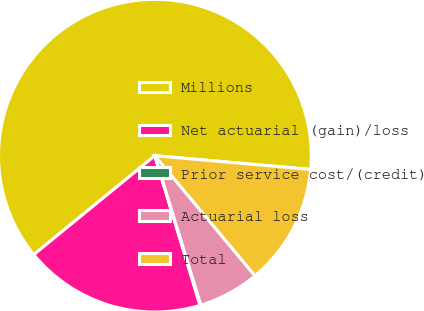<chart> <loc_0><loc_0><loc_500><loc_500><pie_chart><fcel>Millions<fcel>Net actuarial (gain)/loss<fcel>Prior service cost/(credit)<fcel>Actuarial loss<fcel>Total<nl><fcel>62.3%<fcel>18.76%<fcel>0.09%<fcel>6.31%<fcel>12.53%<nl></chart> 